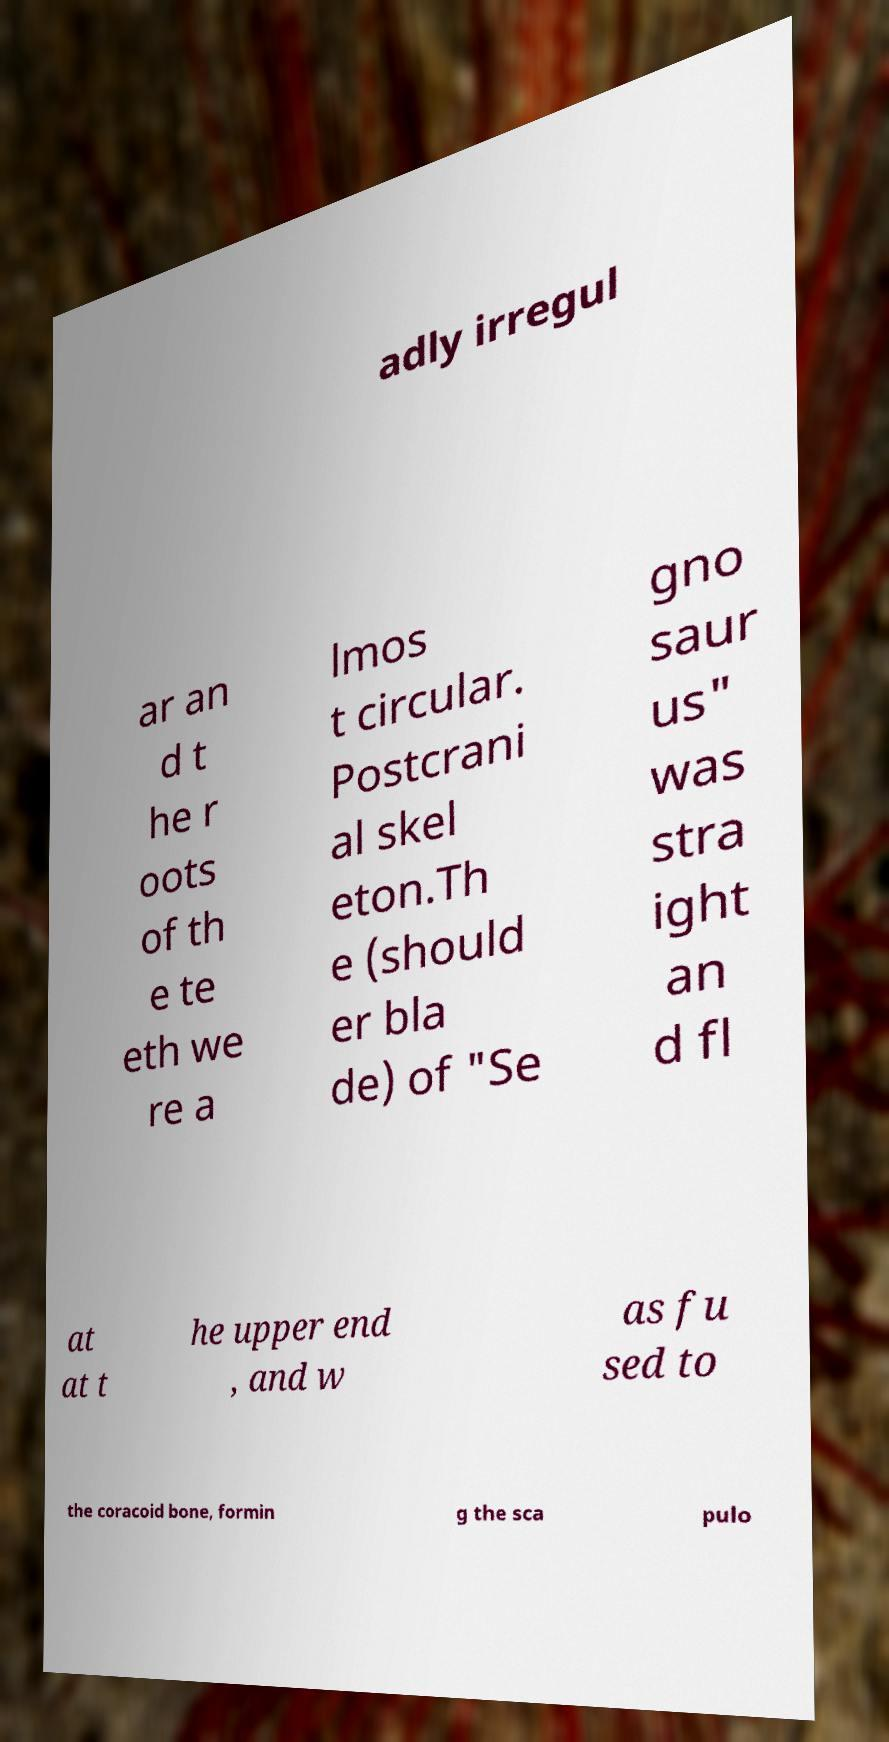Could you assist in decoding the text presented in this image and type it out clearly? adly irregul ar an d t he r oots of th e te eth we re a lmos t circular. Postcrani al skel eton.Th e (should er bla de) of "Se gno saur us" was stra ight an d fl at at t he upper end , and w as fu sed to the coracoid bone, formin g the sca pulo 